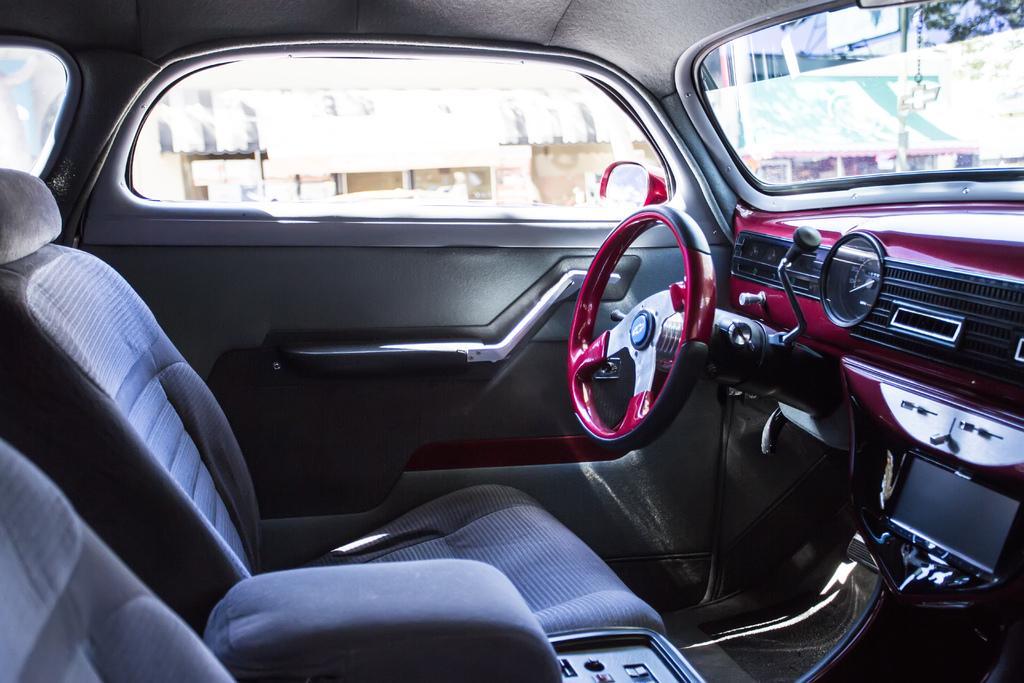How would you summarize this image in a sentence or two? In this image we can see an inside view of a car. To the right side of the image we can see a steering wheel, dials and a screen. In the foreground we can see two seats. in the background, we can see a door, a mirror, group of buildings and tree. 